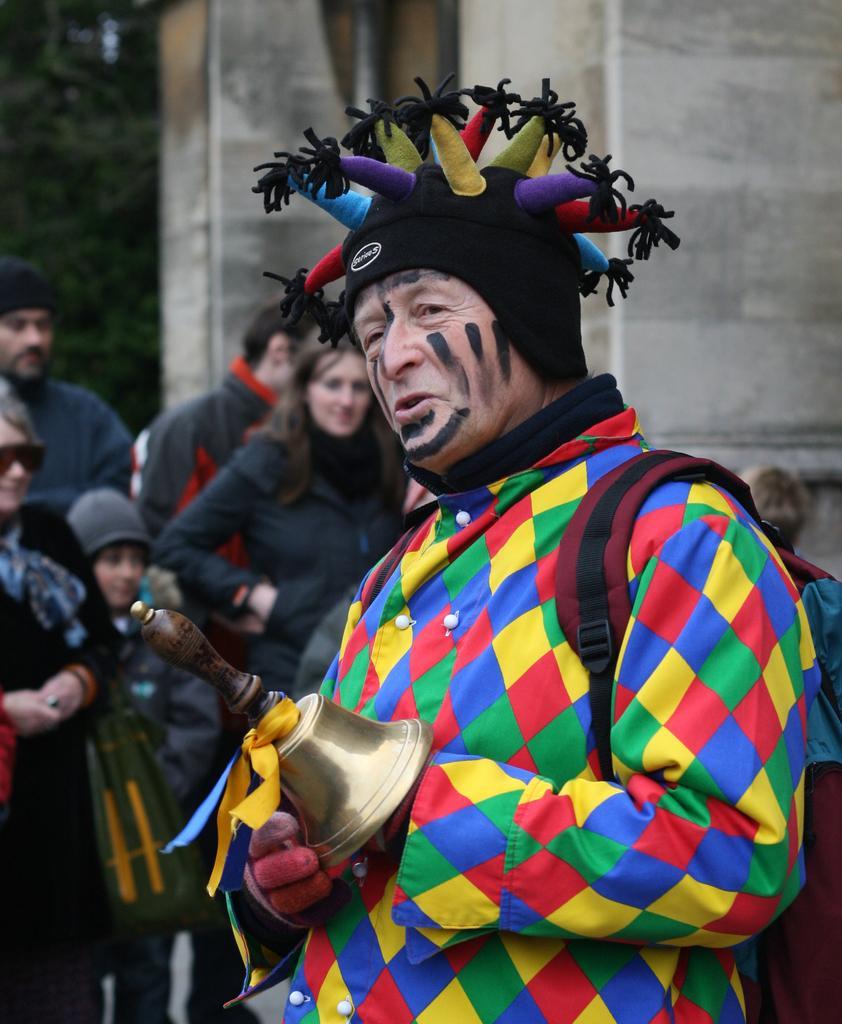In one or two sentences, can you explain what this image depicts? In this image we can see there is a person standing in a different costume and he is holding an object, behind him there are a few people standing. In the background there is a building and trees. 